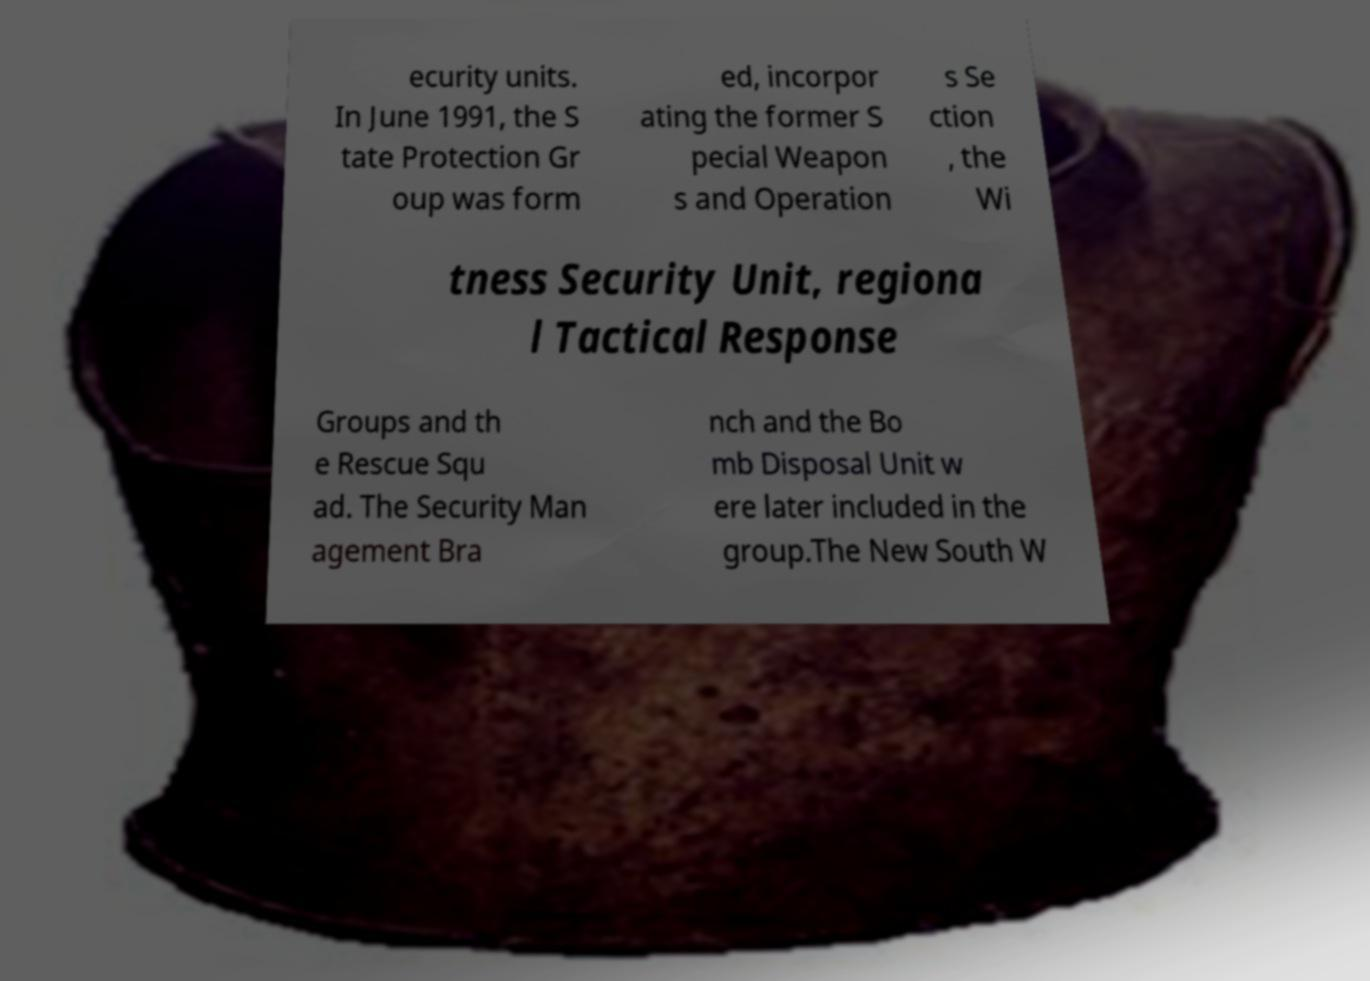Please identify and transcribe the text found in this image. ecurity units. In June 1991, the S tate Protection Gr oup was form ed, incorpor ating the former S pecial Weapon s and Operation s Se ction , the Wi tness Security Unit, regiona l Tactical Response Groups and th e Rescue Squ ad. The Security Man agement Bra nch and the Bo mb Disposal Unit w ere later included in the group.The New South W 